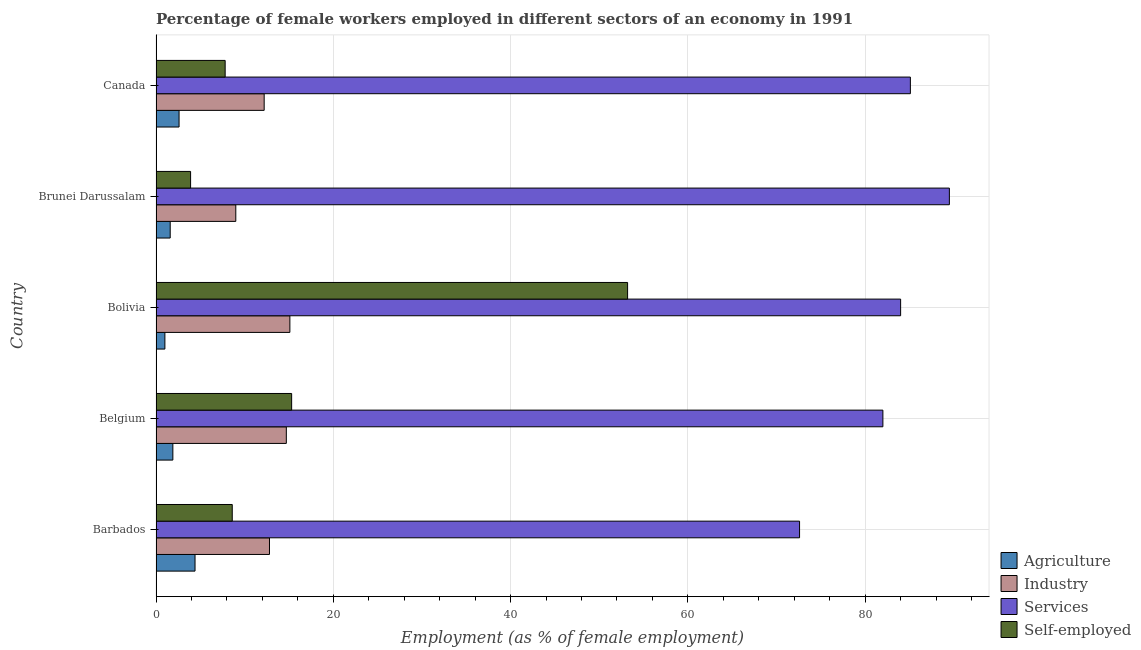Are the number of bars per tick equal to the number of legend labels?
Offer a terse response. Yes. How many bars are there on the 1st tick from the top?
Your response must be concise. 4. In how many cases, is the number of bars for a given country not equal to the number of legend labels?
Your answer should be very brief. 0. What is the percentage of self employed female workers in Brunei Darussalam?
Ensure brevity in your answer.  3.9. Across all countries, what is the maximum percentage of self employed female workers?
Provide a succinct answer. 53.2. Across all countries, what is the minimum percentage of self employed female workers?
Make the answer very short. 3.9. In which country was the percentage of female workers in services maximum?
Your answer should be compact. Brunei Darussalam. In which country was the percentage of female workers in services minimum?
Your response must be concise. Barbados. What is the total percentage of female workers in agriculture in the graph?
Your answer should be compact. 11.5. What is the difference between the percentage of female workers in agriculture in Brunei Darussalam and that in Canada?
Offer a very short reply. -1. What is the difference between the percentage of female workers in industry in Bolivia and the percentage of female workers in services in Brunei Darussalam?
Offer a terse response. -74.4. What is the average percentage of female workers in services per country?
Offer a terse response. 82.64. In how many countries, is the percentage of self employed female workers greater than 24 %?
Offer a very short reply. 1. What is the ratio of the percentage of female workers in industry in Barbados to that in Canada?
Your response must be concise. 1.05. What is the difference between the highest and the second highest percentage of female workers in industry?
Your answer should be compact. 0.4. What is the difference between the highest and the lowest percentage of self employed female workers?
Give a very brief answer. 49.3. In how many countries, is the percentage of female workers in services greater than the average percentage of female workers in services taken over all countries?
Offer a terse response. 3. Is the sum of the percentage of female workers in agriculture in Barbados and Canada greater than the maximum percentage of female workers in industry across all countries?
Make the answer very short. No. What does the 1st bar from the top in Barbados represents?
Provide a succinct answer. Self-employed. What does the 1st bar from the bottom in Barbados represents?
Provide a short and direct response. Agriculture. How many bars are there?
Offer a terse response. 20. Are all the bars in the graph horizontal?
Your answer should be compact. Yes. How many countries are there in the graph?
Your answer should be compact. 5. Are the values on the major ticks of X-axis written in scientific E-notation?
Your answer should be very brief. No. Does the graph contain grids?
Offer a terse response. Yes. Where does the legend appear in the graph?
Provide a short and direct response. Bottom right. How many legend labels are there?
Make the answer very short. 4. What is the title of the graph?
Give a very brief answer. Percentage of female workers employed in different sectors of an economy in 1991. Does "HFC gas" appear as one of the legend labels in the graph?
Provide a short and direct response. No. What is the label or title of the X-axis?
Ensure brevity in your answer.  Employment (as % of female employment). What is the Employment (as % of female employment) of Agriculture in Barbados?
Offer a very short reply. 4.4. What is the Employment (as % of female employment) in Industry in Barbados?
Give a very brief answer. 12.8. What is the Employment (as % of female employment) of Services in Barbados?
Ensure brevity in your answer.  72.6. What is the Employment (as % of female employment) in Self-employed in Barbados?
Provide a succinct answer. 8.6. What is the Employment (as % of female employment) in Agriculture in Belgium?
Offer a terse response. 1.9. What is the Employment (as % of female employment) of Industry in Belgium?
Offer a terse response. 14.7. What is the Employment (as % of female employment) in Services in Belgium?
Provide a short and direct response. 82. What is the Employment (as % of female employment) in Self-employed in Belgium?
Give a very brief answer. 15.3. What is the Employment (as % of female employment) in Agriculture in Bolivia?
Offer a very short reply. 1. What is the Employment (as % of female employment) of Industry in Bolivia?
Ensure brevity in your answer.  15.1. What is the Employment (as % of female employment) of Self-employed in Bolivia?
Ensure brevity in your answer.  53.2. What is the Employment (as % of female employment) of Agriculture in Brunei Darussalam?
Ensure brevity in your answer.  1.6. What is the Employment (as % of female employment) in Services in Brunei Darussalam?
Provide a short and direct response. 89.5. What is the Employment (as % of female employment) of Self-employed in Brunei Darussalam?
Your answer should be very brief. 3.9. What is the Employment (as % of female employment) of Agriculture in Canada?
Your answer should be compact. 2.6. What is the Employment (as % of female employment) of Industry in Canada?
Offer a very short reply. 12.2. What is the Employment (as % of female employment) of Services in Canada?
Offer a very short reply. 85.1. What is the Employment (as % of female employment) in Self-employed in Canada?
Ensure brevity in your answer.  7.8. Across all countries, what is the maximum Employment (as % of female employment) in Agriculture?
Ensure brevity in your answer.  4.4. Across all countries, what is the maximum Employment (as % of female employment) of Industry?
Give a very brief answer. 15.1. Across all countries, what is the maximum Employment (as % of female employment) of Services?
Give a very brief answer. 89.5. Across all countries, what is the maximum Employment (as % of female employment) of Self-employed?
Provide a short and direct response. 53.2. Across all countries, what is the minimum Employment (as % of female employment) of Agriculture?
Provide a succinct answer. 1. Across all countries, what is the minimum Employment (as % of female employment) of Industry?
Give a very brief answer. 9. Across all countries, what is the minimum Employment (as % of female employment) in Services?
Provide a short and direct response. 72.6. Across all countries, what is the minimum Employment (as % of female employment) in Self-employed?
Provide a succinct answer. 3.9. What is the total Employment (as % of female employment) of Agriculture in the graph?
Provide a succinct answer. 11.5. What is the total Employment (as % of female employment) in Industry in the graph?
Make the answer very short. 63.8. What is the total Employment (as % of female employment) of Services in the graph?
Offer a terse response. 413.2. What is the total Employment (as % of female employment) in Self-employed in the graph?
Offer a very short reply. 88.8. What is the difference between the Employment (as % of female employment) of Self-employed in Barbados and that in Belgium?
Keep it short and to the point. -6.7. What is the difference between the Employment (as % of female employment) in Agriculture in Barbados and that in Bolivia?
Your response must be concise. 3.4. What is the difference between the Employment (as % of female employment) of Industry in Barbados and that in Bolivia?
Keep it short and to the point. -2.3. What is the difference between the Employment (as % of female employment) in Self-employed in Barbados and that in Bolivia?
Your response must be concise. -44.6. What is the difference between the Employment (as % of female employment) in Services in Barbados and that in Brunei Darussalam?
Offer a very short reply. -16.9. What is the difference between the Employment (as % of female employment) of Services in Barbados and that in Canada?
Keep it short and to the point. -12.5. What is the difference between the Employment (as % of female employment) in Self-employed in Belgium and that in Bolivia?
Your answer should be very brief. -37.9. What is the difference between the Employment (as % of female employment) of Self-employed in Belgium and that in Brunei Darussalam?
Your answer should be compact. 11.4. What is the difference between the Employment (as % of female employment) of Agriculture in Belgium and that in Canada?
Offer a very short reply. -0.7. What is the difference between the Employment (as % of female employment) of Industry in Belgium and that in Canada?
Your answer should be compact. 2.5. What is the difference between the Employment (as % of female employment) of Self-employed in Belgium and that in Canada?
Give a very brief answer. 7.5. What is the difference between the Employment (as % of female employment) in Agriculture in Bolivia and that in Brunei Darussalam?
Offer a very short reply. -0.6. What is the difference between the Employment (as % of female employment) in Industry in Bolivia and that in Brunei Darussalam?
Ensure brevity in your answer.  6.1. What is the difference between the Employment (as % of female employment) of Services in Bolivia and that in Brunei Darussalam?
Make the answer very short. -5.5. What is the difference between the Employment (as % of female employment) of Self-employed in Bolivia and that in Brunei Darussalam?
Make the answer very short. 49.3. What is the difference between the Employment (as % of female employment) of Services in Bolivia and that in Canada?
Ensure brevity in your answer.  -1.1. What is the difference between the Employment (as % of female employment) in Self-employed in Bolivia and that in Canada?
Give a very brief answer. 45.4. What is the difference between the Employment (as % of female employment) of Industry in Brunei Darussalam and that in Canada?
Keep it short and to the point. -3.2. What is the difference between the Employment (as % of female employment) in Services in Brunei Darussalam and that in Canada?
Your response must be concise. 4.4. What is the difference between the Employment (as % of female employment) of Agriculture in Barbados and the Employment (as % of female employment) of Services in Belgium?
Your answer should be very brief. -77.6. What is the difference between the Employment (as % of female employment) in Agriculture in Barbados and the Employment (as % of female employment) in Self-employed in Belgium?
Your answer should be very brief. -10.9. What is the difference between the Employment (as % of female employment) of Industry in Barbados and the Employment (as % of female employment) of Services in Belgium?
Offer a very short reply. -69.2. What is the difference between the Employment (as % of female employment) of Industry in Barbados and the Employment (as % of female employment) of Self-employed in Belgium?
Provide a succinct answer. -2.5. What is the difference between the Employment (as % of female employment) of Services in Barbados and the Employment (as % of female employment) of Self-employed in Belgium?
Make the answer very short. 57.3. What is the difference between the Employment (as % of female employment) in Agriculture in Barbados and the Employment (as % of female employment) in Services in Bolivia?
Your answer should be very brief. -79.6. What is the difference between the Employment (as % of female employment) of Agriculture in Barbados and the Employment (as % of female employment) of Self-employed in Bolivia?
Provide a short and direct response. -48.8. What is the difference between the Employment (as % of female employment) of Industry in Barbados and the Employment (as % of female employment) of Services in Bolivia?
Give a very brief answer. -71.2. What is the difference between the Employment (as % of female employment) of Industry in Barbados and the Employment (as % of female employment) of Self-employed in Bolivia?
Ensure brevity in your answer.  -40.4. What is the difference between the Employment (as % of female employment) in Services in Barbados and the Employment (as % of female employment) in Self-employed in Bolivia?
Offer a terse response. 19.4. What is the difference between the Employment (as % of female employment) of Agriculture in Barbados and the Employment (as % of female employment) of Industry in Brunei Darussalam?
Your response must be concise. -4.6. What is the difference between the Employment (as % of female employment) in Agriculture in Barbados and the Employment (as % of female employment) in Services in Brunei Darussalam?
Ensure brevity in your answer.  -85.1. What is the difference between the Employment (as % of female employment) in Industry in Barbados and the Employment (as % of female employment) in Services in Brunei Darussalam?
Provide a short and direct response. -76.7. What is the difference between the Employment (as % of female employment) in Services in Barbados and the Employment (as % of female employment) in Self-employed in Brunei Darussalam?
Ensure brevity in your answer.  68.7. What is the difference between the Employment (as % of female employment) in Agriculture in Barbados and the Employment (as % of female employment) in Industry in Canada?
Your answer should be very brief. -7.8. What is the difference between the Employment (as % of female employment) in Agriculture in Barbados and the Employment (as % of female employment) in Services in Canada?
Your answer should be compact. -80.7. What is the difference between the Employment (as % of female employment) in Agriculture in Barbados and the Employment (as % of female employment) in Self-employed in Canada?
Ensure brevity in your answer.  -3.4. What is the difference between the Employment (as % of female employment) in Industry in Barbados and the Employment (as % of female employment) in Services in Canada?
Make the answer very short. -72.3. What is the difference between the Employment (as % of female employment) in Industry in Barbados and the Employment (as % of female employment) in Self-employed in Canada?
Your response must be concise. 5. What is the difference between the Employment (as % of female employment) of Services in Barbados and the Employment (as % of female employment) of Self-employed in Canada?
Offer a very short reply. 64.8. What is the difference between the Employment (as % of female employment) of Agriculture in Belgium and the Employment (as % of female employment) of Services in Bolivia?
Your answer should be very brief. -82.1. What is the difference between the Employment (as % of female employment) of Agriculture in Belgium and the Employment (as % of female employment) of Self-employed in Bolivia?
Make the answer very short. -51.3. What is the difference between the Employment (as % of female employment) of Industry in Belgium and the Employment (as % of female employment) of Services in Bolivia?
Provide a short and direct response. -69.3. What is the difference between the Employment (as % of female employment) of Industry in Belgium and the Employment (as % of female employment) of Self-employed in Bolivia?
Make the answer very short. -38.5. What is the difference between the Employment (as % of female employment) of Services in Belgium and the Employment (as % of female employment) of Self-employed in Bolivia?
Provide a succinct answer. 28.8. What is the difference between the Employment (as % of female employment) of Agriculture in Belgium and the Employment (as % of female employment) of Industry in Brunei Darussalam?
Offer a very short reply. -7.1. What is the difference between the Employment (as % of female employment) of Agriculture in Belgium and the Employment (as % of female employment) of Services in Brunei Darussalam?
Your response must be concise. -87.6. What is the difference between the Employment (as % of female employment) of Agriculture in Belgium and the Employment (as % of female employment) of Self-employed in Brunei Darussalam?
Your answer should be compact. -2. What is the difference between the Employment (as % of female employment) of Industry in Belgium and the Employment (as % of female employment) of Services in Brunei Darussalam?
Make the answer very short. -74.8. What is the difference between the Employment (as % of female employment) in Industry in Belgium and the Employment (as % of female employment) in Self-employed in Brunei Darussalam?
Make the answer very short. 10.8. What is the difference between the Employment (as % of female employment) in Services in Belgium and the Employment (as % of female employment) in Self-employed in Brunei Darussalam?
Offer a terse response. 78.1. What is the difference between the Employment (as % of female employment) of Agriculture in Belgium and the Employment (as % of female employment) of Industry in Canada?
Ensure brevity in your answer.  -10.3. What is the difference between the Employment (as % of female employment) in Agriculture in Belgium and the Employment (as % of female employment) in Services in Canada?
Provide a succinct answer. -83.2. What is the difference between the Employment (as % of female employment) of Industry in Belgium and the Employment (as % of female employment) of Services in Canada?
Ensure brevity in your answer.  -70.4. What is the difference between the Employment (as % of female employment) of Industry in Belgium and the Employment (as % of female employment) of Self-employed in Canada?
Give a very brief answer. 6.9. What is the difference between the Employment (as % of female employment) in Services in Belgium and the Employment (as % of female employment) in Self-employed in Canada?
Offer a terse response. 74.2. What is the difference between the Employment (as % of female employment) of Agriculture in Bolivia and the Employment (as % of female employment) of Industry in Brunei Darussalam?
Make the answer very short. -8. What is the difference between the Employment (as % of female employment) of Agriculture in Bolivia and the Employment (as % of female employment) of Services in Brunei Darussalam?
Offer a very short reply. -88.5. What is the difference between the Employment (as % of female employment) in Industry in Bolivia and the Employment (as % of female employment) in Services in Brunei Darussalam?
Offer a very short reply. -74.4. What is the difference between the Employment (as % of female employment) in Services in Bolivia and the Employment (as % of female employment) in Self-employed in Brunei Darussalam?
Provide a short and direct response. 80.1. What is the difference between the Employment (as % of female employment) of Agriculture in Bolivia and the Employment (as % of female employment) of Industry in Canada?
Make the answer very short. -11.2. What is the difference between the Employment (as % of female employment) in Agriculture in Bolivia and the Employment (as % of female employment) in Services in Canada?
Provide a succinct answer. -84.1. What is the difference between the Employment (as % of female employment) in Agriculture in Bolivia and the Employment (as % of female employment) in Self-employed in Canada?
Keep it short and to the point. -6.8. What is the difference between the Employment (as % of female employment) in Industry in Bolivia and the Employment (as % of female employment) in Services in Canada?
Offer a very short reply. -70. What is the difference between the Employment (as % of female employment) of Industry in Bolivia and the Employment (as % of female employment) of Self-employed in Canada?
Keep it short and to the point. 7.3. What is the difference between the Employment (as % of female employment) in Services in Bolivia and the Employment (as % of female employment) in Self-employed in Canada?
Provide a short and direct response. 76.2. What is the difference between the Employment (as % of female employment) of Agriculture in Brunei Darussalam and the Employment (as % of female employment) of Services in Canada?
Your answer should be very brief. -83.5. What is the difference between the Employment (as % of female employment) of Agriculture in Brunei Darussalam and the Employment (as % of female employment) of Self-employed in Canada?
Your answer should be very brief. -6.2. What is the difference between the Employment (as % of female employment) of Industry in Brunei Darussalam and the Employment (as % of female employment) of Services in Canada?
Ensure brevity in your answer.  -76.1. What is the difference between the Employment (as % of female employment) in Industry in Brunei Darussalam and the Employment (as % of female employment) in Self-employed in Canada?
Ensure brevity in your answer.  1.2. What is the difference between the Employment (as % of female employment) in Services in Brunei Darussalam and the Employment (as % of female employment) in Self-employed in Canada?
Ensure brevity in your answer.  81.7. What is the average Employment (as % of female employment) in Industry per country?
Your response must be concise. 12.76. What is the average Employment (as % of female employment) in Services per country?
Provide a short and direct response. 82.64. What is the average Employment (as % of female employment) in Self-employed per country?
Make the answer very short. 17.76. What is the difference between the Employment (as % of female employment) of Agriculture and Employment (as % of female employment) of Services in Barbados?
Provide a succinct answer. -68.2. What is the difference between the Employment (as % of female employment) in Agriculture and Employment (as % of female employment) in Self-employed in Barbados?
Offer a terse response. -4.2. What is the difference between the Employment (as % of female employment) of Industry and Employment (as % of female employment) of Services in Barbados?
Ensure brevity in your answer.  -59.8. What is the difference between the Employment (as % of female employment) in Industry and Employment (as % of female employment) in Self-employed in Barbados?
Give a very brief answer. 4.2. What is the difference between the Employment (as % of female employment) in Agriculture and Employment (as % of female employment) in Industry in Belgium?
Provide a succinct answer. -12.8. What is the difference between the Employment (as % of female employment) in Agriculture and Employment (as % of female employment) in Services in Belgium?
Make the answer very short. -80.1. What is the difference between the Employment (as % of female employment) of Industry and Employment (as % of female employment) of Services in Belgium?
Your response must be concise. -67.3. What is the difference between the Employment (as % of female employment) in Services and Employment (as % of female employment) in Self-employed in Belgium?
Provide a succinct answer. 66.7. What is the difference between the Employment (as % of female employment) of Agriculture and Employment (as % of female employment) of Industry in Bolivia?
Make the answer very short. -14.1. What is the difference between the Employment (as % of female employment) in Agriculture and Employment (as % of female employment) in Services in Bolivia?
Ensure brevity in your answer.  -83. What is the difference between the Employment (as % of female employment) of Agriculture and Employment (as % of female employment) of Self-employed in Bolivia?
Your response must be concise. -52.2. What is the difference between the Employment (as % of female employment) of Industry and Employment (as % of female employment) of Services in Bolivia?
Your answer should be compact. -68.9. What is the difference between the Employment (as % of female employment) of Industry and Employment (as % of female employment) of Self-employed in Bolivia?
Provide a succinct answer. -38.1. What is the difference between the Employment (as % of female employment) in Services and Employment (as % of female employment) in Self-employed in Bolivia?
Your answer should be very brief. 30.8. What is the difference between the Employment (as % of female employment) in Agriculture and Employment (as % of female employment) in Services in Brunei Darussalam?
Ensure brevity in your answer.  -87.9. What is the difference between the Employment (as % of female employment) of Agriculture and Employment (as % of female employment) of Self-employed in Brunei Darussalam?
Ensure brevity in your answer.  -2.3. What is the difference between the Employment (as % of female employment) of Industry and Employment (as % of female employment) of Services in Brunei Darussalam?
Offer a very short reply. -80.5. What is the difference between the Employment (as % of female employment) in Services and Employment (as % of female employment) in Self-employed in Brunei Darussalam?
Provide a short and direct response. 85.6. What is the difference between the Employment (as % of female employment) of Agriculture and Employment (as % of female employment) of Services in Canada?
Keep it short and to the point. -82.5. What is the difference between the Employment (as % of female employment) of Agriculture and Employment (as % of female employment) of Self-employed in Canada?
Make the answer very short. -5.2. What is the difference between the Employment (as % of female employment) in Industry and Employment (as % of female employment) in Services in Canada?
Offer a very short reply. -72.9. What is the difference between the Employment (as % of female employment) of Industry and Employment (as % of female employment) of Self-employed in Canada?
Provide a short and direct response. 4.4. What is the difference between the Employment (as % of female employment) in Services and Employment (as % of female employment) in Self-employed in Canada?
Offer a very short reply. 77.3. What is the ratio of the Employment (as % of female employment) of Agriculture in Barbados to that in Belgium?
Offer a terse response. 2.32. What is the ratio of the Employment (as % of female employment) in Industry in Barbados to that in Belgium?
Offer a very short reply. 0.87. What is the ratio of the Employment (as % of female employment) in Services in Barbados to that in Belgium?
Your answer should be very brief. 0.89. What is the ratio of the Employment (as % of female employment) in Self-employed in Barbados to that in Belgium?
Your answer should be compact. 0.56. What is the ratio of the Employment (as % of female employment) of Agriculture in Barbados to that in Bolivia?
Offer a terse response. 4.4. What is the ratio of the Employment (as % of female employment) of Industry in Barbados to that in Bolivia?
Provide a short and direct response. 0.85. What is the ratio of the Employment (as % of female employment) of Services in Barbados to that in Bolivia?
Provide a short and direct response. 0.86. What is the ratio of the Employment (as % of female employment) in Self-employed in Barbados to that in Bolivia?
Offer a very short reply. 0.16. What is the ratio of the Employment (as % of female employment) in Agriculture in Barbados to that in Brunei Darussalam?
Offer a terse response. 2.75. What is the ratio of the Employment (as % of female employment) of Industry in Barbados to that in Brunei Darussalam?
Keep it short and to the point. 1.42. What is the ratio of the Employment (as % of female employment) in Services in Barbados to that in Brunei Darussalam?
Keep it short and to the point. 0.81. What is the ratio of the Employment (as % of female employment) of Self-employed in Barbados to that in Brunei Darussalam?
Make the answer very short. 2.21. What is the ratio of the Employment (as % of female employment) in Agriculture in Barbados to that in Canada?
Keep it short and to the point. 1.69. What is the ratio of the Employment (as % of female employment) in Industry in Barbados to that in Canada?
Offer a very short reply. 1.05. What is the ratio of the Employment (as % of female employment) in Services in Barbados to that in Canada?
Offer a terse response. 0.85. What is the ratio of the Employment (as % of female employment) of Self-employed in Barbados to that in Canada?
Make the answer very short. 1.1. What is the ratio of the Employment (as % of female employment) of Industry in Belgium to that in Bolivia?
Offer a terse response. 0.97. What is the ratio of the Employment (as % of female employment) in Services in Belgium to that in Bolivia?
Provide a succinct answer. 0.98. What is the ratio of the Employment (as % of female employment) in Self-employed in Belgium to that in Bolivia?
Your answer should be compact. 0.29. What is the ratio of the Employment (as % of female employment) of Agriculture in Belgium to that in Brunei Darussalam?
Ensure brevity in your answer.  1.19. What is the ratio of the Employment (as % of female employment) in Industry in Belgium to that in Brunei Darussalam?
Ensure brevity in your answer.  1.63. What is the ratio of the Employment (as % of female employment) in Services in Belgium to that in Brunei Darussalam?
Your response must be concise. 0.92. What is the ratio of the Employment (as % of female employment) of Self-employed in Belgium to that in Brunei Darussalam?
Provide a short and direct response. 3.92. What is the ratio of the Employment (as % of female employment) in Agriculture in Belgium to that in Canada?
Your answer should be very brief. 0.73. What is the ratio of the Employment (as % of female employment) of Industry in Belgium to that in Canada?
Your answer should be compact. 1.2. What is the ratio of the Employment (as % of female employment) of Services in Belgium to that in Canada?
Your answer should be compact. 0.96. What is the ratio of the Employment (as % of female employment) of Self-employed in Belgium to that in Canada?
Keep it short and to the point. 1.96. What is the ratio of the Employment (as % of female employment) in Industry in Bolivia to that in Brunei Darussalam?
Provide a short and direct response. 1.68. What is the ratio of the Employment (as % of female employment) of Services in Bolivia to that in Brunei Darussalam?
Offer a terse response. 0.94. What is the ratio of the Employment (as % of female employment) of Self-employed in Bolivia to that in Brunei Darussalam?
Give a very brief answer. 13.64. What is the ratio of the Employment (as % of female employment) in Agriculture in Bolivia to that in Canada?
Provide a short and direct response. 0.38. What is the ratio of the Employment (as % of female employment) of Industry in Bolivia to that in Canada?
Keep it short and to the point. 1.24. What is the ratio of the Employment (as % of female employment) of Services in Bolivia to that in Canada?
Keep it short and to the point. 0.99. What is the ratio of the Employment (as % of female employment) in Self-employed in Bolivia to that in Canada?
Give a very brief answer. 6.82. What is the ratio of the Employment (as % of female employment) of Agriculture in Brunei Darussalam to that in Canada?
Keep it short and to the point. 0.62. What is the ratio of the Employment (as % of female employment) of Industry in Brunei Darussalam to that in Canada?
Make the answer very short. 0.74. What is the ratio of the Employment (as % of female employment) in Services in Brunei Darussalam to that in Canada?
Provide a succinct answer. 1.05. What is the difference between the highest and the second highest Employment (as % of female employment) of Agriculture?
Give a very brief answer. 1.8. What is the difference between the highest and the second highest Employment (as % of female employment) of Services?
Provide a succinct answer. 4.4. What is the difference between the highest and the second highest Employment (as % of female employment) in Self-employed?
Offer a terse response. 37.9. What is the difference between the highest and the lowest Employment (as % of female employment) of Self-employed?
Offer a terse response. 49.3. 